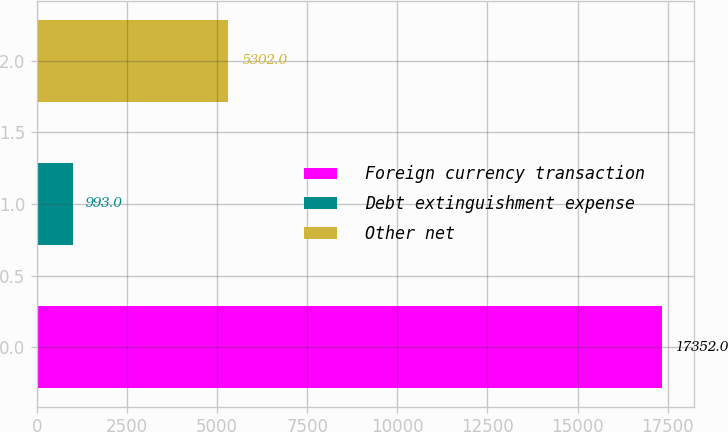<chart> <loc_0><loc_0><loc_500><loc_500><bar_chart><fcel>Foreign currency transaction<fcel>Debt extinguishment expense<fcel>Other net<nl><fcel>17352<fcel>993<fcel>5302<nl></chart> 